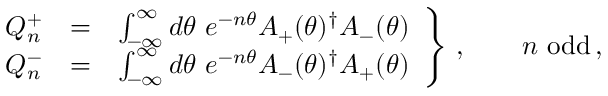Convert formula to latex. <formula><loc_0><loc_0><loc_500><loc_500>\begin{array} { r c l } { { Q _ { n } ^ { + } } } & { = } & { { \int _ { - \infty } ^ { \infty } d \theta \ e ^ { - n \theta } A _ { + } ( \theta ) ^ { \dagger } A _ { - } ( \theta ) } } \\ { { Q _ { n } ^ { - } } } & { = } & { { \int _ { - \infty } ^ { \infty } d \theta \ e ^ { - n \theta } A _ { - } ( \theta ) ^ { \dagger } A _ { + } ( \theta ) } } \end{array} \right \} \, , \quad n { o d d } \, ,</formula> 